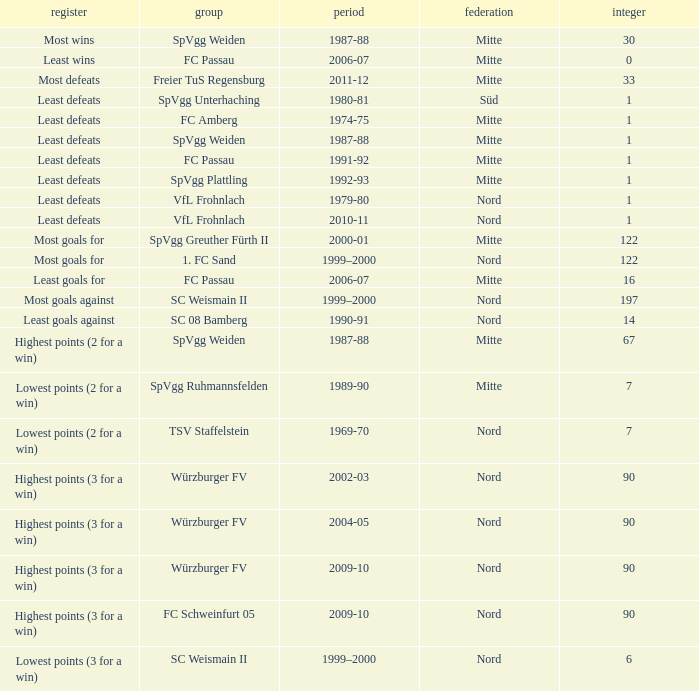What league has most wins as the record? Mitte. Help me parse the entirety of this table. {'header': ['register', 'group', 'period', 'federation', 'integer'], 'rows': [['Most wins', 'SpVgg Weiden', '1987-88', 'Mitte', '30'], ['Least wins', 'FC Passau', '2006-07', 'Mitte', '0'], ['Most defeats', 'Freier TuS Regensburg', '2011-12', 'Mitte', '33'], ['Least defeats', 'SpVgg Unterhaching', '1980-81', 'Süd', '1'], ['Least defeats', 'FC Amberg', '1974-75', 'Mitte', '1'], ['Least defeats', 'SpVgg Weiden', '1987-88', 'Mitte', '1'], ['Least defeats', 'FC Passau', '1991-92', 'Mitte', '1'], ['Least defeats', 'SpVgg Plattling', '1992-93', 'Mitte', '1'], ['Least defeats', 'VfL Frohnlach', '1979-80', 'Nord', '1'], ['Least defeats', 'VfL Frohnlach', '2010-11', 'Nord', '1'], ['Most goals for', 'SpVgg Greuther Fürth II', '2000-01', 'Mitte', '122'], ['Most goals for', '1. FC Sand', '1999–2000', 'Nord', '122'], ['Least goals for', 'FC Passau', '2006-07', 'Mitte', '16'], ['Most goals against', 'SC Weismain II', '1999–2000', 'Nord', '197'], ['Least goals against', 'SC 08 Bamberg', '1990-91', 'Nord', '14'], ['Highest points (2 for a win)', 'SpVgg Weiden', '1987-88', 'Mitte', '67'], ['Lowest points (2 for a win)', 'SpVgg Ruhmannsfelden', '1989-90', 'Mitte', '7'], ['Lowest points (2 for a win)', 'TSV Staffelstein', '1969-70', 'Nord', '7'], ['Highest points (3 for a win)', 'Würzburger FV', '2002-03', 'Nord', '90'], ['Highest points (3 for a win)', 'Würzburger FV', '2004-05', 'Nord', '90'], ['Highest points (3 for a win)', 'Würzburger FV', '2009-10', 'Nord', '90'], ['Highest points (3 for a win)', 'FC Schweinfurt 05', '2009-10', 'Nord', '90'], ['Lowest points (3 for a win)', 'SC Weismain II', '1999–2000', 'Nord', '6']]} 